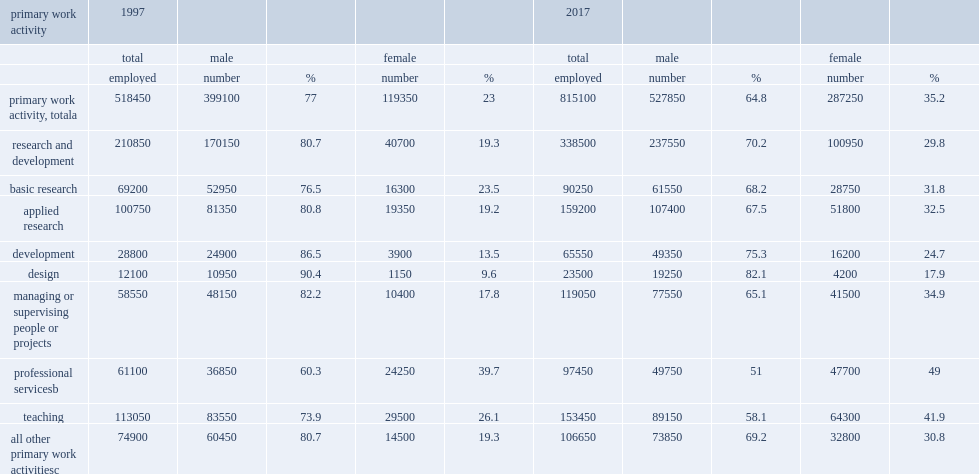In 2017, how many percent of u.s.-trained seh doctorate holders performing an r&d activity as their primary work activity were women? 29.8. In 1997, how many percent of u.s.-trained seh doctorate holders performing an r&d activity as their primary work activity were women? 19.3. 